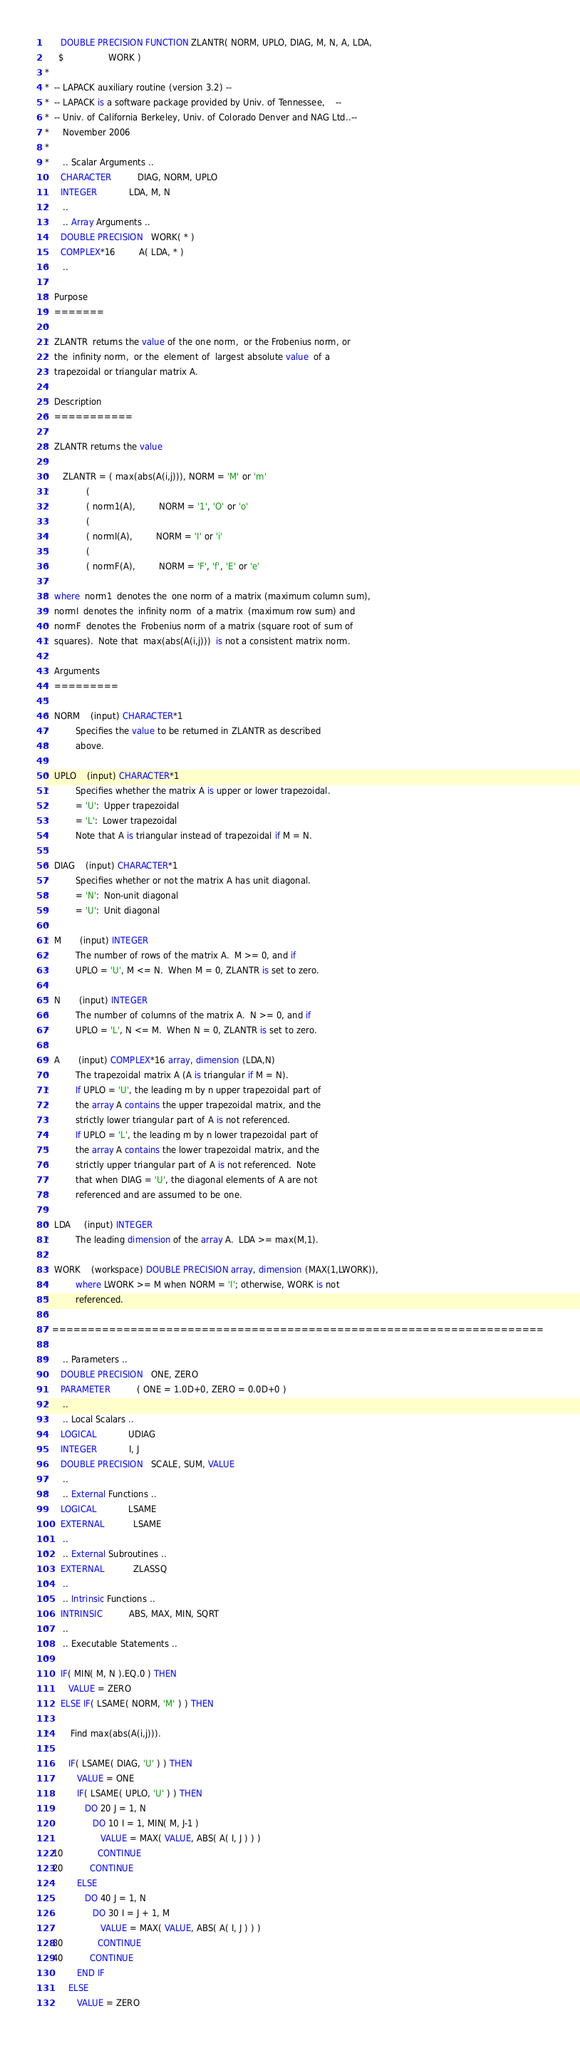<code> <loc_0><loc_0><loc_500><loc_500><_FORTRAN_>      DOUBLE PRECISION FUNCTION ZLANTR( NORM, UPLO, DIAG, M, N, A, LDA,
     $                 WORK )
*
*  -- LAPACK auxiliary routine (version 3.2) --
*  -- LAPACK is a software package provided by Univ. of Tennessee,    --
*  -- Univ. of California Berkeley, Univ. of Colorado Denver and NAG Ltd..--
*     November 2006
*
*     .. Scalar Arguments ..
      CHARACTER          DIAG, NORM, UPLO
      INTEGER            LDA, M, N
*     ..
*     .. Array Arguments ..
      DOUBLE PRECISION   WORK( * )
      COMPLEX*16         A( LDA, * )
*     ..
*
*  Purpose
*  =======
*
*  ZLANTR  returns the value of the one norm,  or the Frobenius norm, or
*  the  infinity norm,  or the  element of  largest absolute value  of a
*  trapezoidal or triangular matrix A.
*
*  Description
*  ===========
*
*  ZLANTR returns the value
*
*     ZLANTR = ( max(abs(A(i,j))), NORM = 'M' or 'm'
*              (
*              ( norm1(A),         NORM = '1', 'O' or 'o'
*              (
*              ( normI(A),         NORM = 'I' or 'i'
*              (
*              ( normF(A),         NORM = 'F', 'f', 'E' or 'e'
*
*  where  norm1  denotes the  one norm of a matrix (maximum column sum),
*  normI  denotes the  infinity norm  of a matrix  (maximum row sum) and
*  normF  denotes the  Frobenius norm of a matrix (square root of sum of
*  squares).  Note that  max(abs(A(i,j)))  is not a consistent matrix norm.
*
*  Arguments
*  =========
*
*  NORM    (input) CHARACTER*1
*          Specifies the value to be returned in ZLANTR as described
*          above.
*
*  UPLO    (input) CHARACTER*1
*          Specifies whether the matrix A is upper or lower trapezoidal.
*          = 'U':  Upper trapezoidal
*          = 'L':  Lower trapezoidal
*          Note that A is triangular instead of trapezoidal if M = N.
*
*  DIAG    (input) CHARACTER*1
*          Specifies whether or not the matrix A has unit diagonal.
*          = 'N':  Non-unit diagonal
*          = 'U':  Unit diagonal
*
*  M       (input) INTEGER
*          The number of rows of the matrix A.  M >= 0, and if
*          UPLO = 'U', M <= N.  When M = 0, ZLANTR is set to zero.
*
*  N       (input) INTEGER
*          The number of columns of the matrix A.  N >= 0, and if
*          UPLO = 'L', N <= M.  When N = 0, ZLANTR is set to zero.
*
*  A       (input) COMPLEX*16 array, dimension (LDA,N)
*          The trapezoidal matrix A (A is triangular if M = N).
*          If UPLO = 'U', the leading m by n upper trapezoidal part of
*          the array A contains the upper trapezoidal matrix, and the
*          strictly lower triangular part of A is not referenced.
*          If UPLO = 'L', the leading m by n lower trapezoidal part of
*          the array A contains the lower trapezoidal matrix, and the
*          strictly upper triangular part of A is not referenced.  Note
*          that when DIAG = 'U', the diagonal elements of A are not
*          referenced and are assumed to be one.
*
*  LDA     (input) INTEGER
*          The leading dimension of the array A.  LDA >= max(M,1).
*
*  WORK    (workspace) DOUBLE PRECISION array, dimension (MAX(1,LWORK)),
*          where LWORK >= M when NORM = 'I'; otherwise, WORK is not
*          referenced.
*
* =====================================================================
*
*     .. Parameters ..
      DOUBLE PRECISION   ONE, ZERO
      PARAMETER          ( ONE = 1.0D+0, ZERO = 0.0D+0 )
*     ..
*     .. Local Scalars ..
      LOGICAL            UDIAG
      INTEGER            I, J
      DOUBLE PRECISION   SCALE, SUM, VALUE
*     ..
*     .. External Functions ..
      LOGICAL            LSAME
      EXTERNAL           LSAME
*     ..
*     .. External Subroutines ..
      EXTERNAL           ZLASSQ
*     ..
*     .. Intrinsic Functions ..
      INTRINSIC          ABS, MAX, MIN, SQRT
*     ..
*     .. Executable Statements ..
*
      IF( MIN( M, N ).EQ.0 ) THEN
         VALUE = ZERO
      ELSE IF( LSAME( NORM, 'M' ) ) THEN
*
*        Find max(abs(A(i,j))).
*
         IF( LSAME( DIAG, 'U' ) ) THEN
            VALUE = ONE
            IF( LSAME( UPLO, 'U' ) ) THEN
               DO 20 J = 1, N
                  DO 10 I = 1, MIN( M, J-1 )
                     VALUE = MAX( VALUE, ABS( A( I, J ) ) )
   10             CONTINUE
   20          CONTINUE
            ELSE
               DO 40 J = 1, N
                  DO 30 I = J + 1, M
                     VALUE = MAX( VALUE, ABS( A( I, J ) ) )
   30             CONTINUE
   40          CONTINUE
            END IF
         ELSE
            VALUE = ZERO</code> 